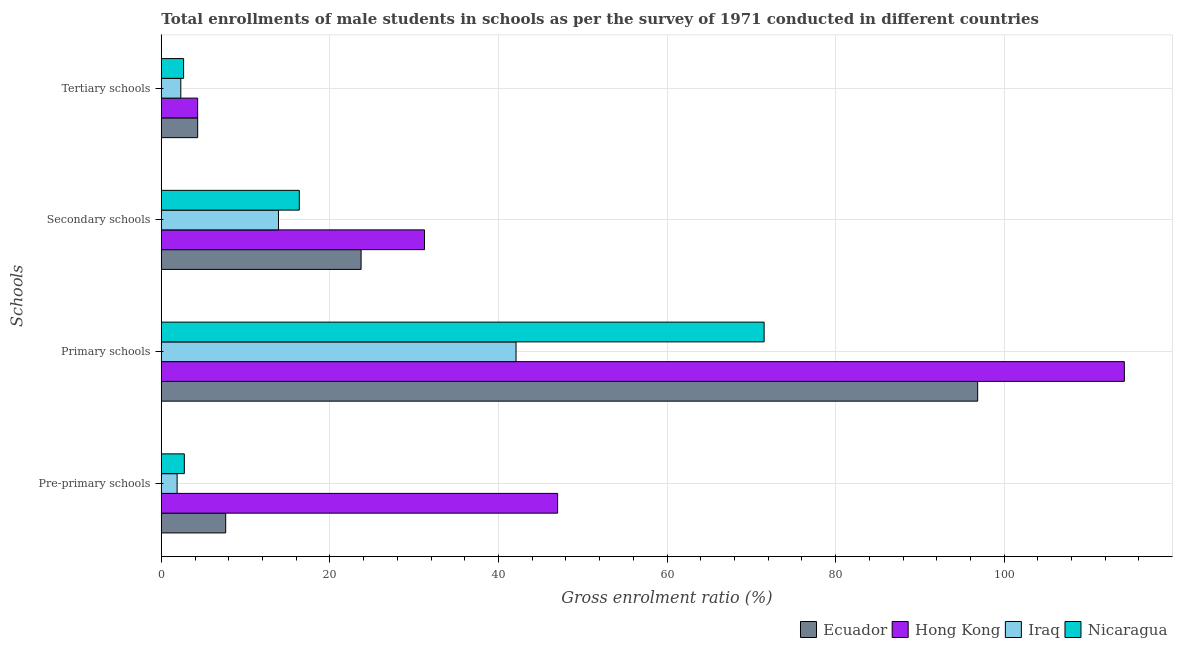Are the number of bars on each tick of the Y-axis equal?
Your answer should be compact. Yes. How many bars are there on the 2nd tick from the top?
Give a very brief answer. 4. What is the label of the 3rd group of bars from the top?
Make the answer very short. Primary schools. What is the gross enrolment ratio(male) in pre-primary schools in Nicaragua?
Your response must be concise. 2.73. Across all countries, what is the maximum gross enrolment ratio(male) in tertiary schools?
Your response must be concise. 4.31. Across all countries, what is the minimum gross enrolment ratio(male) in pre-primary schools?
Offer a very short reply. 1.87. In which country was the gross enrolment ratio(male) in primary schools maximum?
Your answer should be compact. Hong Kong. In which country was the gross enrolment ratio(male) in tertiary schools minimum?
Keep it short and to the point. Iraq. What is the total gross enrolment ratio(male) in secondary schools in the graph?
Provide a succinct answer. 85.21. What is the difference between the gross enrolment ratio(male) in primary schools in Nicaragua and that in Ecuador?
Your answer should be compact. -25.34. What is the difference between the gross enrolment ratio(male) in pre-primary schools in Ecuador and the gross enrolment ratio(male) in secondary schools in Nicaragua?
Give a very brief answer. -8.73. What is the average gross enrolment ratio(male) in tertiary schools per country?
Make the answer very short. 3.39. What is the difference between the gross enrolment ratio(male) in pre-primary schools and gross enrolment ratio(male) in tertiary schools in Ecuador?
Ensure brevity in your answer.  3.33. What is the ratio of the gross enrolment ratio(male) in secondary schools in Nicaragua to that in Hong Kong?
Offer a very short reply. 0.52. Is the gross enrolment ratio(male) in pre-primary schools in Iraq less than that in Nicaragua?
Ensure brevity in your answer.  Yes. What is the difference between the highest and the second highest gross enrolment ratio(male) in tertiary schools?
Provide a succinct answer. 0. What is the difference between the highest and the lowest gross enrolment ratio(male) in pre-primary schools?
Offer a very short reply. 45.15. In how many countries, is the gross enrolment ratio(male) in secondary schools greater than the average gross enrolment ratio(male) in secondary schools taken over all countries?
Give a very brief answer. 2. Is the sum of the gross enrolment ratio(male) in secondary schools in Ecuador and Iraq greater than the maximum gross enrolment ratio(male) in primary schools across all countries?
Keep it short and to the point. No. Is it the case that in every country, the sum of the gross enrolment ratio(male) in pre-primary schools and gross enrolment ratio(male) in secondary schools is greater than the sum of gross enrolment ratio(male) in tertiary schools and gross enrolment ratio(male) in primary schools?
Give a very brief answer. No. What does the 1st bar from the top in Secondary schools represents?
Offer a very short reply. Nicaragua. What does the 3rd bar from the bottom in Pre-primary schools represents?
Ensure brevity in your answer.  Iraq. Is it the case that in every country, the sum of the gross enrolment ratio(male) in pre-primary schools and gross enrolment ratio(male) in primary schools is greater than the gross enrolment ratio(male) in secondary schools?
Your answer should be compact. Yes. Are all the bars in the graph horizontal?
Ensure brevity in your answer.  Yes. How many countries are there in the graph?
Keep it short and to the point. 4. What is the difference between two consecutive major ticks on the X-axis?
Your response must be concise. 20. Are the values on the major ticks of X-axis written in scientific E-notation?
Offer a terse response. No. What is the title of the graph?
Ensure brevity in your answer.  Total enrollments of male students in schools as per the survey of 1971 conducted in different countries. Does "Latin America(all income levels)" appear as one of the legend labels in the graph?
Give a very brief answer. No. What is the label or title of the X-axis?
Offer a terse response. Gross enrolment ratio (%). What is the label or title of the Y-axis?
Ensure brevity in your answer.  Schools. What is the Gross enrolment ratio (%) in Ecuador in Pre-primary schools?
Make the answer very short. 7.64. What is the Gross enrolment ratio (%) in Hong Kong in Pre-primary schools?
Your answer should be compact. 47.02. What is the Gross enrolment ratio (%) of Iraq in Pre-primary schools?
Provide a succinct answer. 1.87. What is the Gross enrolment ratio (%) of Nicaragua in Pre-primary schools?
Provide a succinct answer. 2.73. What is the Gross enrolment ratio (%) in Ecuador in Primary schools?
Give a very brief answer. 96.86. What is the Gross enrolment ratio (%) in Hong Kong in Primary schools?
Provide a short and direct response. 114.26. What is the Gross enrolment ratio (%) of Iraq in Primary schools?
Give a very brief answer. 42.09. What is the Gross enrolment ratio (%) of Nicaragua in Primary schools?
Offer a terse response. 71.52. What is the Gross enrolment ratio (%) of Ecuador in Secondary schools?
Offer a very short reply. 23.7. What is the Gross enrolment ratio (%) in Hong Kong in Secondary schools?
Offer a very short reply. 31.23. What is the Gross enrolment ratio (%) in Iraq in Secondary schools?
Offer a very short reply. 13.9. What is the Gross enrolment ratio (%) in Nicaragua in Secondary schools?
Ensure brevity in your answer.  16.37. What is the Gross enrolment ratio (%) of Ecuador in Tertiary schools?
Provide a succinct answer. 4.31. What is the Gross enrolment ratio (%) of Hong Kong in Tertiary schools?
Keep it short and to the point. 4.31. What is the Gross enrolment ratio (%) in Iraq in Tertiary schools?
Keep it short and to the point. 2.31. What is the Gross enrolment ratio (%) of Nicaragua in Tertiary schools?
Provide a short and direct response. 2.64. Across all Schools, what is the maximum Gross enrolment ratio (%) in Ecuador?
Your answer should be compact. 96.86. Across all Schools, what is the maximum Gross enrolment ratio (%) of Hong Kong?
Provide a succinct answer. 114.26. Across all Schools, what is the maximum Gross enrolment ratio (%) of Iraq?
Ensure brevity in your answer.  42.09. Across all Schools, what is the maximum Gross enrolment ratio (%) of Nicaragua?
Provide a succinct answer. 71.52. Across all Schools, what is the minimum Gross enrolment ratio (%) of Ecuador?
Your response must be concise. 4.31. Across all Schools, what is the minimum Gross enrolment ratio (%) of Hong Kong?
Offer a terse response. 4.31. Across all Schools, what is the minimum Gross enrolment ratio (%) in Iraq?
Ensure brevity in your answer.  1.87. Across all Schools, what is the minimum Gross enrolment ratio (%) of Nicaragua?
Keep it short and to the point. 2.64. What is the total Gross enrolment ratio (%) in Ecuador in the graph?
Provide a short and direct response. 132.52. What is the total Gross enrolment ratio (%) in Hong Kong in the graph?
Provide a succinct answer. 196.82. What is the total Gross enrolment ratio (%) in Iraq in the graph?
Your answer should be very brief. 60.18. What is the total Gross enrolment ratio (%) in Nicaragua in the graph?
Offer a very short reply. 93.27. What is the difference between the Gross enrolment ratio (%) in Ecuador in Pre-primary schools and that in Primary schools?
Offer a very short reply. -89.22. What is the difference between the Gross enrolment ratio (%) of Hong Kong in Pre-primary schools and that in Primary schools?
Make the answer very short. -67.24. What is the difference between the Gross enrolment ratio (%) of Iraq in Pre-primary schools and that in Primary schools?
Make the answer very short. -40.21. What is the difference between the Gross enrolment ratio (%) in Nicaragua in Pre-primary schools and that in Primary schools?
Keep it short and to the point. -68.79. What is the difference between the Gross enrolment ratio (%) in Ecuador in Pre-primary schools and that in Secondary schools?
Your response must be concise. -16.06. What is the difference between the Gross enrolment ratio (%) in Hong Kong in Pre-primary schools and that in Secondary schools?
Ensure brevity in your answer.  15.79. What is the difference between the Gross enrolment ratio (%) of Iraq in Pre-primary schools and that in Secondary schools?
Give a very brief answer. -12.03. What is the difference between the Gross enrolment ratio (%) of Nicaragua in Pre-primary schools and that in Secondary schools?
Make the answer very short. -13.64. What is the difference between the Gross enrolment ratio (%) of Ecuador in Pre-primary schools and that in Tertiary schools?
Your response must be concise. 3.33. What is the difference between the Gross enrolment ratio (%) of Hong Kong in Pre-primary schools and that in Tertiary schools?
Provide a short and direct response. 42.71. What is the difference between the Gross enrolment ratio (%) of Iraq in Pre-primary schools and that in Tertiary schools?
Make the answer very short. -0.44. What is the difference between the Gross enrolment ratio (%) of Nicaragua in Pre-primary schools and that in Tertiary schools?
Your answer should be compact. 0.09. What is the difference between the Gross enrolment ratio (%) in Ecuador in Primary schools and that in Secondary schools?
Ensure brevity in your answer.  73.16. What is the difference between the Gross enrolment ratio (%) in Hong Kong in Primary schools and that in Secondary schools?
Your answer should be very brief. 83.03. What is the difference between the Gross enrolment ratio (%) in Iraq in Primary schools and that in Secondary schools?
Make the answer very short. 28.19. What is the difference between the Gross enrolment ratio (%) of Nicaragua in Primary schools and that in Secondary schools?
Offer a terse response. 55.15. What is the difference between the Gross enrolment ratio (%) of Ecuador in Primary schools and that in Tertiary schools?
Ensure brevity in your answer.  92.55. What is the difference between the Gross enrolment ratio (%) of Hong Kong in Primary schools and that in Tertiary schools?
Make the answer very short. 109.95. What is the difference between the Gross enrolment ratio (%) in Iraq in Primary schools and that in Tertiary schools?
Offer a very short reply. 39.78. What is the difference between the Gross enrolment ratio (%) of Nicaragua in Primary schools and that in Tertiary schools?
Offer a very short reply. 68.88. What is the difference between the Gross enrolment ratio (%) in Ecuador in Secondary schools and that in Tertiary schools?
Keep it short and to the point. 19.39. What is the difference between the Gross enrolment ratio (%) of Hong Kong in Secondary schools and that in Tertiary schools?
Offer a very short reply. 26.92. What is the difference between the Gross enrolment ratio (%) of Iraq in Secondary schools and that in Tertiary schools?
Your answer should be very brief. 11.59. What is the difference between the Gross enrolment ratio (%) of Nicaragua in Secondary schools and that in Tertiary schools?
Your answer should be compact. 13.73. What is the difference between the Gross enrolment ratio (%) of Ecuador in Pre-primary schools and the Gross enrolment ratio (%) of Hong Kong in Primary schools?
Offer a very short reply. -106.62. What is the difference between the Gross enrolment ratio (%) in Ecuador in Pre-primary schools and the Gross enrolment ratio (%) in Iraq in Primary schools?
Keep it short and to the point. -34.45. What is the difference between the Gross enrolment ratio (%) in Ecuador in Pre-primary schools and the Gross enrolment ratio (%) in Nicaragua in Primary schools?
Make the answer very short. -63.88. What is the difference between the Gross enrolment ratio (%) in Hong Kong in Pre-primary schools and the Gross enrolment ratio (%) in Iraq in Primary schools?
Make the answer very short. 4.93. What is the difference between the Gross enrolment ratio (%) of Hong Kong in Pre-primary schools and the Gross enrolment ratio (%) of Nicaragua in Primary schools?
Provide a succinct answer. -24.5. What is the difference between the Gross enrolment ratio (%) of Iraq in Pre-primary schools and the Gross enrolment ratio (%) of Nicaragua in Primary schools?
Your response must be concise. -69.65. What is the difference between the Gross enrolment ratio (%) of Ecuador in Pre-primary schools and the Gross enrolment ratio (%) of Hong Kong in Secondary schools?
Provide a short and direct response. -23.59. What is the difference between the Gross enrolment ratio (%) of Ecuador in Pre-primary schools and the Gross enrolment ratio (%) of Iraq in Secondary schools?
Make the answer very short. -6.26. What is the difference between the Gross enrolment ratio (%) in Ecuador in Pre-primary schools and the Gross enrolment ratio (%) in Nicaragua in Secondary schools?
Your answer should be compact. -8.73. What is the difference between the Gross enrolment ratio (%) in Hong Kong in Pre-primary schools and the Gross enrolment ratio (%) in Iraq in Secondary schools?
Your answer should be very brief. 33.12. What is the difference between the Gross enrolment ratio (%) in Hong Kong in Pre-primary schools and the Gross enrolment ratio (%) in Nicaragua in Secondary schools?
Provide a succinct answer. 30.65. What is the difference between the Gross enrolment ratio (%) in Iraq in Pre-primary schools and the Gross enrolment ratio (%) in Nicaragua in Secondary schools?
Your response must be concise. -14.5. What is the difference between the Gross enrolment ratio (%) in Ecuador in Pre-primary schools and the Gross enrolment ratio (%) in Hong Kong in Tertiary schools?
Provide a succinct answer. 3.33. What is the difference between the Gross enrolment ratio (%) of Ecuador in Pre-primary schools and the Gross enrolment ratio (%) of Iraq in Tertiary schools?
Give a very brief answer. 5.33. What is the difference between the Gross enrolment ratio (%) of Ecuador in Pre-primary schools and the Gross enrolment ratio (%) of Nicaragua in Tertiary schools?
Make the answer very short. 5. What is the difference between the Gross enrolment ratio (%) in Hong Kong in Pre-primary schools and the Gross enrolment ratio (%) in Iraq in Tertiary schools?
Ensure brevity in your answer.  44.71. What is the difference between the Gross enrolment ratio (%) of Hong Kong in Pre-primary schools and the Gross enrolment ratio (%) of Nicaragua in Tertiary schools?
Your response must be concise. 44.38. What is the difference between the Gross enrolment ratio (%) in Iraq in Pre-primary schools and the Gross enrolment ratio (%) in Nicaragua in Tertiary schools?
Offer a terse response. -0.77. What is the difference between the Gross enrolment ratio (%) in Ecuador in Primary schools and the Gross enrolment ratio (%) in Hong Kong in Secondary schools?
Offer a very short reply. 65.63. What is the difference between the Gross enrolment ratio (%) in Ecuador in Primary schools and the Gross enrolment ratio (%) in Iraq in Secondary schools?
Offer a very short reply. 82.96. What is the difference between the Gross enrolment ratio (%) in Ecuador in Primary schools and the Gross enrolment ratio (%) in Nicaragua in Secondary schools?
Make the answer very short. 80.49. What is the difference between the Gross enrolment ratio (%) in Hong Kong in Primary schools and the Gross enrolment ratio (%) in Iraq in Secondary schools?
Your answer should be very brief. 100.36. What is the difference between the Gross enrolment ratio (%) in Hong Kong in Primary schools and the Gross enrolment ratio (%) in Nicaragua in Secondary schools?
Give a very brief answer. 97.89. What is the difference between the Gross enrolment ratio (%) in Iraq in Primary schools and the Gross enrolment ratio (%) in Nicaragua in Secondary schools?
Your answer should be compact. 25.72. What is the difference between the Gross enrolment ratio (%) in Ecuador in Primary schools and the Gross enrolment ratio (%) in Hong Kong in Tertiary schools?
Offer a terse response. 92.55. What is the difference between the Gross enrolment ratio (%) of Ecuador in Primary schools and the Gross enrolment ratio (%) of Iraq in Tertiary schools?
Your answer should be very brief. 94.55. What is the difference between the Gross enrolment ratio (%) of Ecuador in Primary schools and the Gross enrolment ratio (%) of Nicaragua in Tertiary schools?
Keep it short and to the point. 94.22. What is the difference between the Gross enrolment ratio (%) in Hong Kong in Primary schools and the Gross enrolment ratio (%) in Iraq in Tertiary schools?
Provide a short and direct response. 111.95. What is the difference between the Gross enrolment ratio (%) in Hong Kong in Primary schools and the Gross enrolment ratio (%) in Nicaragua in Tertiary schools?
Your answer should be compact. 111.62. What is the difference between the Gross enrolment ratio (%) in Iraq in Primary schools and the Gross enrolment ratio (%) in Nicaragua in Tertiary schools?
Your answer should be very brief. 39.44. What is the difference between the Gross enrolment ratio (%) in Ecuador in Secondary schools and the Gross enrolment ratio (%) in Hong Kong in Tertiary schools?
Your answer should be very brief. 19.39. What is the difference between the Gross enrolment ratio (%) of Ecuador in Secondary schools and the Gross enrolment ratio (%) of Iraq in Tertiary schools?
Ensure brevity in your answer.  21.39. What is the difference between the Gross enrolment ratio (%) in Ecuador in Secondary schools and the Gross enrolment ratio (%) in Nicaragua in Tertiary schools?
Your answer should be compact. 21.06. What is the difference between the Gross enrolment ratio (%) of Hong Kong in Secondary schools and the Gross enrolment ratio (%) of Iraq in Tertiary schools?
Your response must be concise. 28.92. What is the difference between the Gross enrolment ratio (%) in Hong Kong in Secondary schools and the Gross enrolment ratio (%) in Nicaragua in Tertiary schools?
Provide a short and direct response. 28.58. What is the difference between the Gross enrolment ratio (%) in Iraq in Secondary schools and the Gross enrolment ratio (%) in Nicaragua in Tertiary schools?
Your answer should be compact. 11.26. What is the average Gross enrolment ratio (%) in Ecuador per Schools?
Provide a succinct answer. 33.13. What is the average Gross enrolment ratio (%) of Hong Kong per Schools?
Your response must be concise. 49.21. What is the average Gross enrolment ratio (%) of Iraq per Schools?
Keep it short and to the point. 15.04. What is the average Gross enrolment ratio (%) of Nicaragua per Schools?
Your answer should be very brief. 23.32. What is the difference between the Gross enrolment ratio (%) in Ecuador and Gross enrolment ratio (%) in Hong Kong in Pre-primary schools?
Provide a succinct answer. -39.38. What is the difference between the Gross enrolment ratio (%) of Ecuador and Gross enrolment ratio (%) of Iraq in Pre-primary schools?
Your answer should be compact. 5.77. What is the difference between the Gross enrolment ratio (%) of Ecuador and Gross enrolment ratio (%) of Nicaragua in Pre-primary schools?
Your response must be concise. 4.91. What is the difference between the Gross enrolment ratio (%) in Hong Kong and Gross enrolment ratio (%) in Iraq in Pre-primary schools?
Provide a short and direct response. 45.15. What is the difference between the Gross enrolment ratio (%) of Hong Kong and Gross enrolment ratio (%) of Nicaragua in Pre-primary schools?
Give a very brief answer. 44.29. What is the difference between the Gross enrolment ratio (%) in Iraq and Gross enrolment ratio (%) in Nicaragua in Pre-primary schools?
Offer a very short reply. -0.85. What is the difference between the Gross enrolment ratio (%) of Ecuador and Gross enrolment ratio (%) of Hong Kong in Primary schools?
Offer a terse response. -17.4. What is the difference between the Gross enrolment ratio (%) in Ecuador and Gross enrolment ratio (%) in Iraq in Primary schools?
Keep it short and to the point. 54.77. What is the difference between the Gross enrolment ratio (%) in Ecuador and Gross enrolment ratio (%) in Nicaragua in Primary schools?
Provide a succinct answer. 25.34. What is the difference between the Gross enrolment ratio (%) in Hong Kong and Gross enrolment ratio (%) in Iraq in Primary schools?
Keep it short and to the point. 72.17. What is the difference between the Gross enrolment ratio (%) in Hong Kong and Gross enrolment ratio (%) in Nicaragua in Primary schools?
Make the answer very short. 42.74. What is the difference between the Gross enrolment ratio (%) in Iraq and Gross enrolment ratio (%) in Nicaragua in Primary schools?
Give a very brief answer. -29.44. What is the difference between the Gross enrolment ratio (%) of Ecuador and Gross enrolment ratio (%) of Hong Kong in Secondary schools?
Your response must be concise. -7.53. What is the difference between the Gross enrolment ratio (%) of Ecuador and Gross enrolment ratio (%) of Iraq in Secondary schools?
Keep it short and to the point. 9.8. What is the difference between the Gross enrolment ratio (%) of Ecuador and Gross enrolment ratio (%) of Nicaragua in Secondary schools?
Your answer should be very brief. 7.33. What is the difference between the Gross enrolment ratio (%) in Hong Kong and Gross enrolment ratio (%) in Iraq in Secondary schools?
Ensure brevity in your answer.  17.33. What is the difference between the Gross enrolment ratio (%) of Hong Kong and Gross enrolment ratio (%) of Nicaragua in Secondary schools?
Your answer should be very brief. 14.86. What is the difference between the Gross enrolment ratio (%) of Iraq and Gross enrolment ratio (%) of Nicaragua in Secondary schools?
Ensure brevity in your answer.  -2.47. What is the difference between the Gross enrolment ratio (%) of Ecuador and Gross enrolment ratio (%) of Hong Kong in Tertiary schools?
Make the answer very short. 0. What is the difference between the Gross enrolment ratio (%) in Ecuador and Gross enrolment ratio (%) in Iraq in Tertiary schools?
Your response must be concise. 2. What is the difference between the Gross enrolment ratio (%) of Ecuador and Gross enrolment ratio (%) of Nicaragua in Tertiary schools?
Make the answer very short. 1.67. What is the difference between the Gross enrolment ratio (%) in Hong Kong and Gross enrolment ratio (%) in Iraq in Tertiary schools?
Provide a succinct answer. 2. What is the difference between the Gross enrolment ratio (%) in Hong Kong and Gross enrolment ratio (%) in Nicaragua in Tertiary schools?
Give a very brief answer. 1.66. What is the difference between the Gross enrolment ratio (%) in Iraq and Gross enrolment ratio (%) in Nicaragua in Tertiary schools?
Ensure brevity in your answer.  -0.33. What is the ratio of the Gross enrolment ratio (%) of Ecuador in Pre-primary schools to that in Primary schools?
Your answer should be very brief. 0.08. What is the ratio of the Gross enrolment ratio (%) in Hong Kong in Pre-primary schools to that in Primary schools?
Your answer should be very brief. 0.41. What is the ratio of the Gross enrolment ratio (%) of Iraq in Pre-primary schools to that in Primary schools?
Provide a short and direct response. 0.04. What is the ratio of the Gross enrolment ratio (%) of Nicaragua in Pre-primary schools to that in Primary schools?
Keep it short and to the point. 0.04. What is the ratio of the Gross enrolment ratio (%) of Ecuador in Pre-primary schools to that in Secondary schools?
Provide a short and direct response. 0.32. What is the ratio of the Gross enrolment ratio (%) in Hong Kong in Pre-primary schools to that in Secondary schools?
Provide a short and direct response. 1.51. What is the ratio of the Gross enrolment ratio (%) in Iraq in Pre-primary schools to that in Secondary schools?
Give a very brief answer. 0.13. What is the ratio of the Gross enrolment ratio (%) of Nicaragua in Pre-primary schools to that in Secondary schools?
Your answer should be compact. 0.17. What is the ratio of the Gross enrolment ratio (%) in Ecuador in Pre-primary schools to that in Tertiary schools?
Your answer should be compact. 1.77. What is the ratio of the Gross enrolment ratio (%) in Hong Kong in Pre-primary schools to that in Tertiary schools?
Make the answer very short. 10.91. What is the ratio of the Gross enrolment ratio (%) in Iraq in Pre-primary schools to that in Tertiary schools?
Keep it short and to the point. 0.81. What is the ratio of the Gross enrolment ratio (%) of Nicaragua in Pre-primary schools to that in Tertiary schools?
Make the answer very short. 1.03. What is the ratio of the Gross enrolment ratio (%) in Ecuador in Primary schools to that in Secondary schools?
Your answer should be very brief. 4.09. What is the ratio of the Gross enrolment ratio (%) in Hong Kong in Primary schools to that in Secondary schools?
Your response must be concise. 3.66. What is the ratio of the Gross enrolment ratio (%) of Iraq in Primary schools to that in Secondary schools?
Make the answer very short. 3.03. What is the ratio of the Gross enrolment ratio (%) in Nicaragua in Primary schools to that in Secondary schools?
Offer a very short reply. 4.37. What is the ratio of the Gross enrolment ratio (%) in Ecuador in Primary schools to that in Tertiary schools?
Offer a very short reply. 22.46. What is the ratio of the Gross enrolment ratio (%) of Hong Kong in Primary schools to that in Tertiary schools?
Give a very brief answer. 26.52. What is the ratio of the Gross enrolment ratio (%) of Iraq in Primary schools to that in Tertiary schools?
Provide a short and direct response. 18.2. What is the ratio of the Gross enrolment ratio (%) of Nicaragua in Primary schools to that in Tertiary schools?
Provide a succinct answer. 27.05. What is the ratio of the Gross enrolment ratio (%) in Ecuador in Secondary schools to that in Tertiary schools?
Provide a succinct answer. 5.5. What is the ratio of the Gross enrolment ratio (%) of Hong Kong in Secondary schools to that in Tertiary schools?
Offer a terse response. 7.25. What is the ratio of the Gross enrolment ratio (%) in Iraq in Secondary schools to that in Tertiary schools?
Make the answer very short. 6.01. What is the ratio of the Gross enrolment ratio (%) in Nicaragua in Secondary schools to that in Tertiary schools?
Your response must be concise. 6.19. What is the difference between the highest and the second highest Gross enrolment ratio (%) of Ecuador?
Provide a short and direct response. 73.16. What is the difference between the highest and the second highest Gross enrolment ratio (%) in Hong Kong?
Ensure brevity in your answer.  67.24. What is the difference between the highest and the second highest Gross enrolment ratio (%) of Iraq?
Provide a short and direct response. 28.19. What is the difference between the highest and the second highest Gross enrolment ratio (%) in Nicaragua?
Your answer should be very brief. 55.15. What is the difference between the highest and the lowest Gross enrolment ratio (%) of Ecuador?
Make the answer very short. 92.55. What is the difference between the highest and the lowest Gross enrolment ratio (%) of Hong Kong?
Your response must be concise. 109.95. What is the difference between the highest and the lowest Gross enrolment ratio (%) in Iraq?
Offer a terse response. 40.21. What is the difference between the highest and the lowest Gross enrolment ratio (%) of Nicaragua?
Provide a short and direct response. 68.88. 